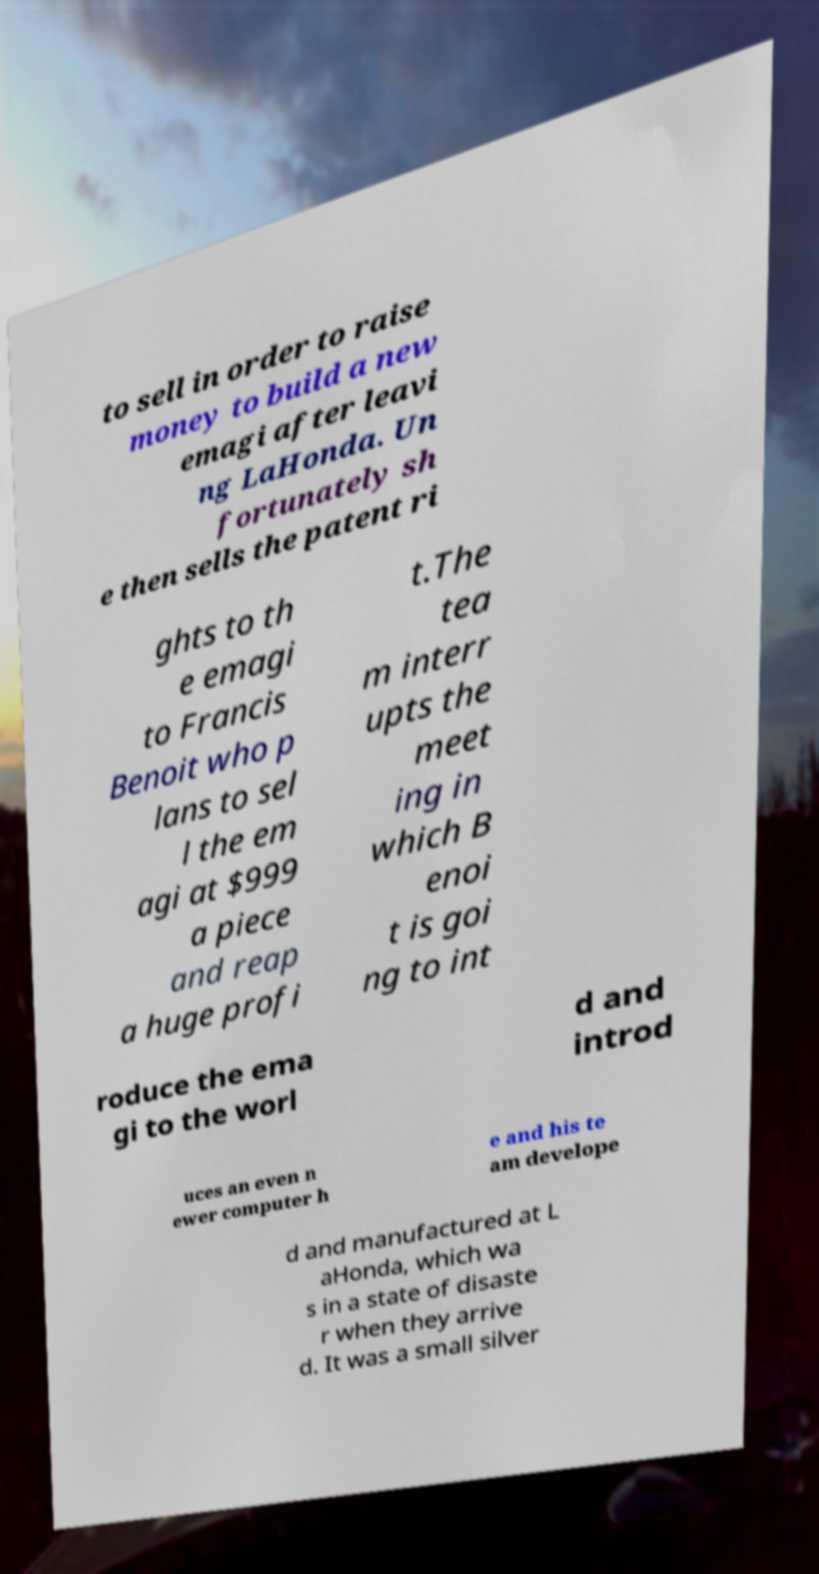There's text embedded in this image that I need extracted. Can you transcribe it verbatim? to sell in order to raise money to build a new emagi after leavi ng LaHonda. Un fortunately sh e then sells the patent ri ghts to th e emagi to Francis Benoit who p lans to sel l the em agi at $999 a piece and reap a huge profi t.The tea m interr upts the meet ing in which B enoi t is goi ng to int roduce the ema gi to the worl d and introd uces an even n ewer computer h e and his te am develope d and manufactured at L aHonda, which wa s in a state of disaste r when they arrive d. It was a small silver 